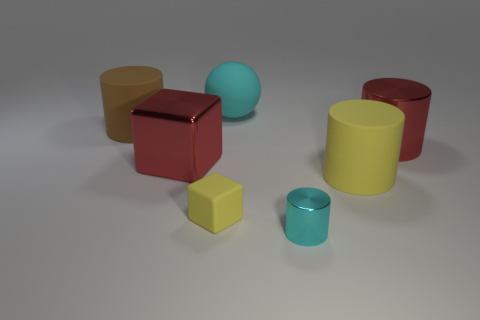Subtract all yellow cylinders. How many cylinders are left? 3 Add 2 big blue metal balls. How many objects exist? 9 Subtract all brown cylinders. How many cylinders are left? 3 Subtract all cylinders. How many objects are left? 3 Add 7 tiny blocks. How many tiny blocks are left? 8 Add 1 large blue spheres. How many large blue spheres exist? 1 Subtract 1 brown cylinders. How many objects are left? 6 Subtract all brown blocks. Subtract all cyan cylinders. How many blocks are left? 2 Subtract all green rubber spheres. Subtract all small yellow blocks. How many objects are left? 6 